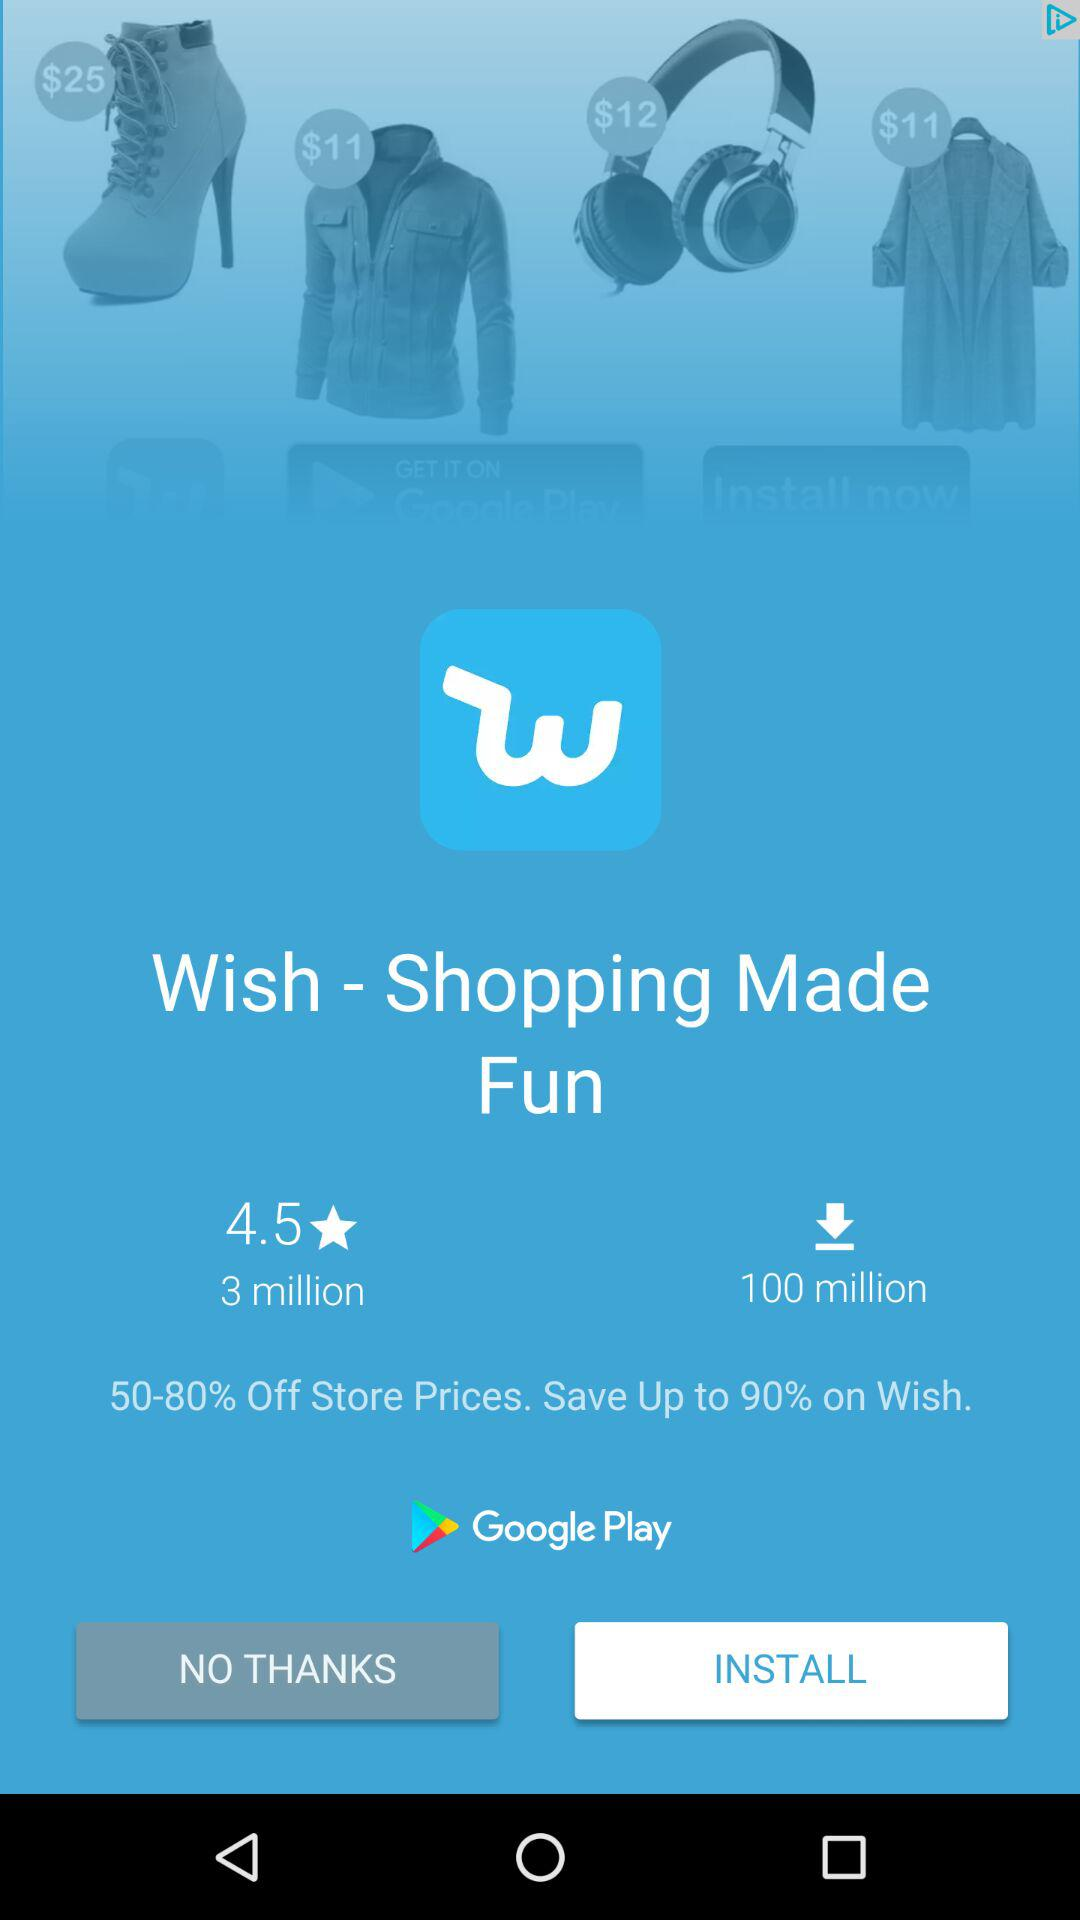How many more downloads does the app have than reviews?
Answer the question using a single word or phrase. 97 million 